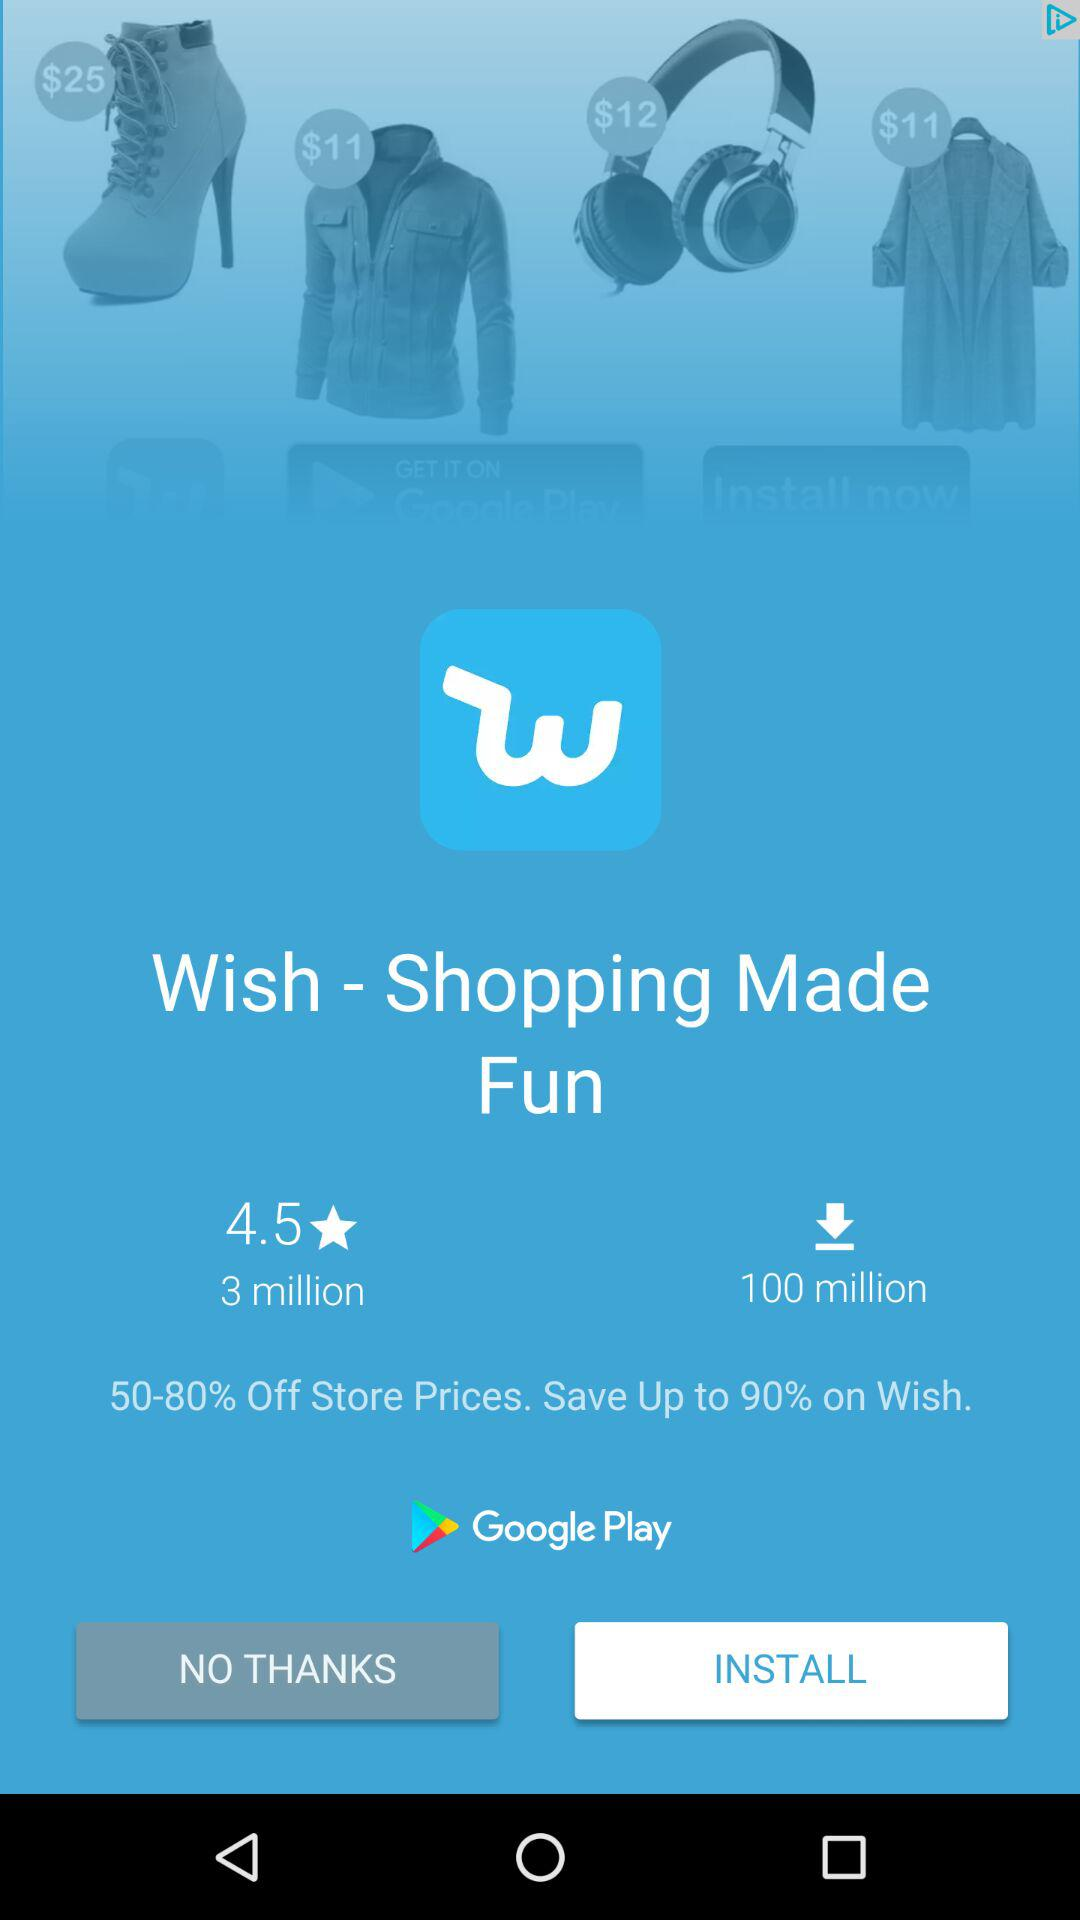How many more downloads does the app have than reviews?
Answer the question using a single word or phrase. 97 million 